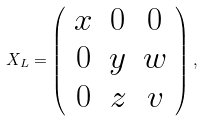Convert formula to latex. <formula><loc_0><loc_0><loc_500><loc_500>X _ { L } = \left ( \begin{array} { c c c } x & 0 & 0 \\ 0 & y & w \\ 0 & z & v \end{array} \right ) ,</formula> 